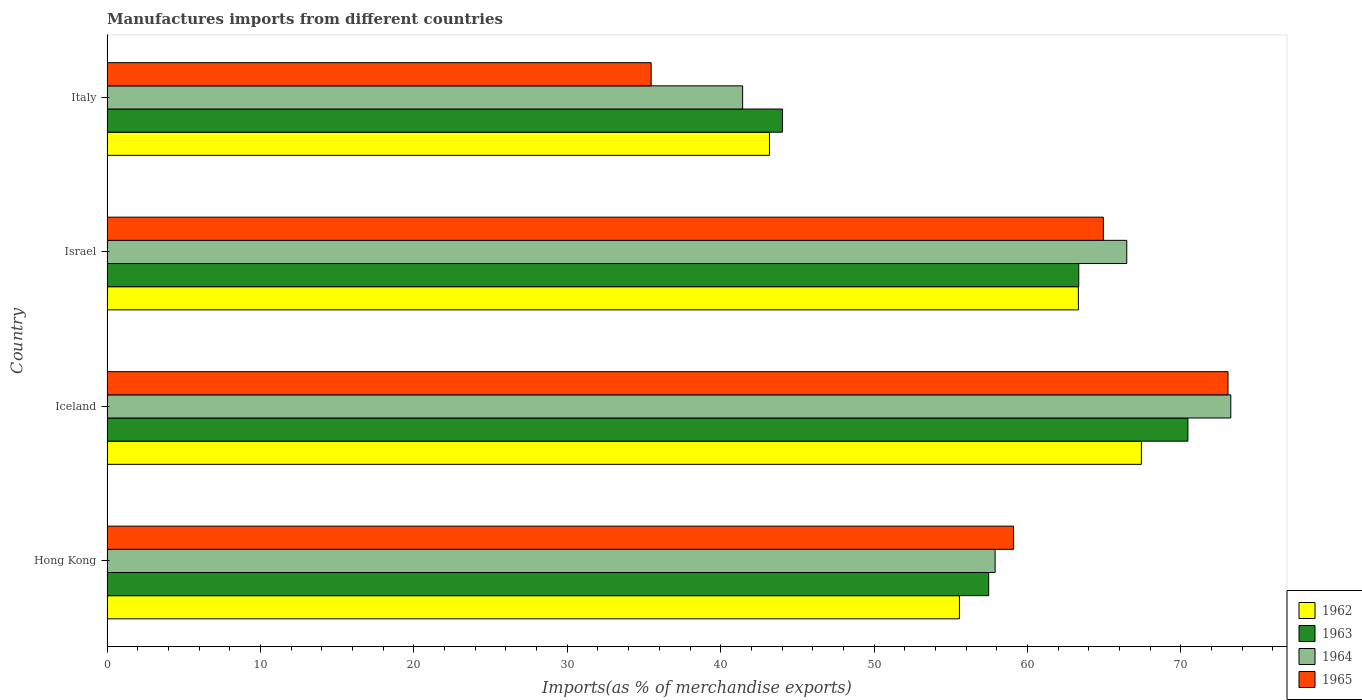How many different coloured bars are there?
Offer a terse response. 4. What is the label of the 4th group of bars from the top?
Ensure brevity in your answer.  Hong Kong. What is the percentage of imports to different countries in 1964 in Hong Kong?
Your answer should be compact. 57.89. Across all countries, what is the maximum percentage of imports to different countries in 1962?
Make the answer very short. 67.42. Across all countries, what is the minimum percentage of imports to different countries in 1963?
Ensure brevity in your answer.  44.02. What is the total percentage of imports to different countries in 1962 in the graph?
Offer a terse response. 229.48. What is the difference between the percentage of imports to different countries in 1964 in Iceland and that in Italy?
Give a very brief answer. 31.82. What is the difference between the percentage of imports to different countries in 1963 in Italy and the percentage of imports to different countries in 1962 in Iceland?
Your answer should be very brief. -23.4. What is the average percentage of imports to different countries in 1963 per country?
Ensure brevity in your answer.  58.82. What is the difference between the percentage of imports to different countries in 1965 and percentage of imports to different countries in 1962 in Italy?
Your answer should be very brief. -7.71. What is the ratio of the percentage of imports to different countries in 1963 in Iceland to that in Israel?
Offer a very short reply. 1.11. Is the percentage of imports to different countries in 1965 in Hong Kong less than that in Israel?
Your response must be concise. Yes. Is the difference between the percentage of imports to different countries in 1965 in Israel and Italy greater than the difference between the percentage of imports to different countries in 1962 in Israel and Italy?
Your response must be concise. Yes. What is the difference between the highest and the second highest percentage of imports to different countries in 1965?
Offer a terse response. 8.12. What is the difference between the highest and the lowest percentage of imports to different countries in 1962?
Provide a short and direct response. 24.24. In how many countries, is the percentage of imports to different countries in 1962 greater than the average percentage of imports to different countries in 1962 taken over all countries?
Ensure brevity in your answer.  2. Is the sum of the percentage of imports to different countries in 1963 in Hong Kong and Iceland greater than the maximum percentage of imports to different countries in 1965 across all countries?
Your answer should be very brief. Yes. What does the 2nd bar from the bottom in Iceland represents?
Your answer should be very brief. 1963. How many countries are there in the graph?
Offer a terse response. 4. What is the difference between two consecutive major ticks on the X-axis?
Ensure brevity in your answer.  10. Are the values on the major ticks of X-axis written in scientific E-notation?
Offer a terse response. No. Does the graph contain any zero values?
Offer a terse response. No. Where does the legend appear in the graph?
Ensure brevity in your answer.  Bottom right. How many legend labels are there?
Make the answer very short. 4. How are the legend labels stacked?
Give a very brief answer. Vertical. What is the title of the graph?
Your answer should be compact. Manufactures imports from different countries. Does "2015" appear as one of the legend labels in the graph?
Your answer should be compact. No. What is the label or title of the X-axis?
Provide a succinct answer. Imports(as % of merchandise exports). What is the Imports(as % of merchandise exports) of 1962 in Hong Kong?
Provide a succinct answer. 55.56. What is the Imports(as % of merchandise exports) in 1963 in Hong Kong?
Your answer should be very brief. 57.47. What is the Imports(as % of merchandise exports) of 1964 in Hong Kong?
Keep it short and to the point. 57.89. What is the Imports(as % of merchandise exports) in 1965 in Hong Kong?
Make the answer very short. 59.09. What is the Imports(as % of merchandise exports) of 1962 in Iceland?
Ensure brevity in your answer.  67.42. What is the Imports(as % of merchandise exports) in 1963 in Iceland?
Keep it short and to the point. 70.45. What is the Imports(as % of merchandise exports) of 1964 in Iceland?
Make the answer very short. 73.25. What is the Imports(as % of merchandise exports) of 1965 in Iceland?
Offer a terse response. 73.07. What is the Imports(as % of merchandise exports) of 1962 in Israel?
Provide a short and direct response. 63.32. What is the Imports(as % of merchandise exports) in 1963 in Israel?
Provide a short and direct response. 63.34. What is the Imports(as % of merchandise exports) in 1964 in Israel?
Your answer should be compact. 66.47. What is the Imports(as % of merchandise exports) in 1965 in Israel?
Make the answer very short. 64.94. What is the Imports(as % of merchandise exports) of 1962 in Italy?
Your answer should be compact. 43.18. What is the Imports(as % of merchandise exports) in 1963 in Italy?
Provide a short and direct response. 44.02. What is the Imports(as % of merchandise exports) in 1964 in Italy?
Offer a very short reply. 41.43. What is the Imports(as % of merchandise exports) of 1965 in Italy?
Provide a succinct answer. 35.47. Across all countries, what is the maximum Imports(as % of merchandise exports) of 1962?
Offer a very short reply. 67.42. Across all countries, what is the maximum Imports(as % of merchandise exports) of 1963?
Provide a short and direct response. 70.45. Across all countries, what is the maximum Imports(as % of merchandise exports) in 1964?
Ensure brevity in your answer.  73.25. Across all countries, what is the maximum Imports(as % of merchandise exports) in 1965?
Give a very brief answer. 73.07. Across all countries, what is the minimum Imports(as % of merchandise exports) of 1962?
Keep it short and to the point. 43.18. Across all countries, what is the minimum Imports(as % of merchandise exports) in 1963?
Offer a very short reply. 44.02. Across all countries, what is the minimum Imports(as % of merchandise exports) in 1964?
Your answer should be very brief. 41.43. Across all countries, what is the minimum Imports(as % of merchandise exports) in 1965?
Ensure brevity in your answer.  35.47. What is the total Imports(as % of merchandise exports) of 1962 in the graph?
Keep it short and to the point. 229.48. What is the total Imports(as % of merchandise exports) in 1963 in the graph?
Offer a very short reply. 235.29. What is the total Imports(as % of merchandise exports) of 1964 in the graph?
Make the answer very short. 239.04. What is the total Imports(as % of merchandise exports) of 1965 in the graph?
Provide a short and direct response. 232.57. What is the difference between the Imports(as % of merchandise exports) in 1962 in Hong Kong and that in Iceland?
Your answer should be compact. -11.86. What is the difference between the Imports(as % of merchandise exports) of 1963 in Hong Kong and that in Iceland?
Offer a very short reply. -12.98. What is the difference between the Imports(as % of merchandise exports) in 1964 in Hong Kong and that in Iceland?
Your answer should be very brief. -15.36. What is the difference between the Imports(as % of merchandise exports) of 1965 in Hong Kong and that in Iceland?
Your answer should be compact. -13.98. What is the difference between the Imports(as % of merchandise exports) in 1962 in Hong Kong and that in Israel?
Provide a short and direct response. -7.75. What is the difference between the Imports(as % of merchandise exports) in 1963 in Hong Kong and that in Israel?
Offer a very short reply. -5.87. What is the difference between the Imports(as % of merchandise exports) of 1964 in Hong Kong and that in Israel?
Your answer should be compact. -8.58. What is the difference between the Imports(as % of merchandise exports) of 1965 in Hong Kong and that in Israel?
Provide a succinct answer. -5.85. What is the difference between the Imports(as % of merchandise exports) in 1962 in Hong Kong and that in Italy?
Give a very brief answer. 12.38. What is the difference between the Imports(as % of merchandise exports) in 1963 in Hong Kong and that in Italy?
Your answer should be very brief. 13.44. What is the difference between the Imports(as % of merchandise exports) of 1964 in Hong Kong and that in Italy?
Make the answer very short. 16.46. What is the difference between the Imports(as % of merchandise exports) in 1965 in Hong Kong and that in Italy?
Your answer should be compact. 23.62. What is the difference between the Imports(as % of merchandise exports) in 1962 in Iceland and that in Israel?
Ensure brevity in your answer.  4.11. What is the difference between the Imports(as % of merchandise exports) of 1963 in Iceland and that in Israel?
Offer a terse response. 7.11. What is the difference between the Imports(as % of merchandise exports) in 1964 in Iceland and that in Israel?
Offer a very short reply. 6.78. What is the difference between the Imports(as % of merchandise exports) in 1965 in Iceland and that in Israel?
Keep it short and to the point. 8.12. What is the difference between the Imports(as % of merchandise exports) in 1962 in Iceland and that in Italy?
Your answer should be compact. 24.24. What is the difference between the Imports(as % of merchandise exports) in 1963 in Iceland and that in Italy?
Offer a very short reply. 26.43. What is the difference between the Imports(as % of merchandise exports) of 1964 in Iceland and that in Italy?
Offer a very short reply. 31.82. What is the difference between the Imports(as % of merchandise exports) of 1965 in Iceland and that in Italy?
Your response must be concise. 37.6. What is the difference between the Imports(as % of merchandise exports) in 1962 in Israel and that in Italy?
Provide a succinct answer. 20.14. What is the difference between the Imports(as % of merchandise exports) in 1963 in Israel and that in Italy?
Provide a succinct answer. 19.32. What is the difference between the Imports(as % of merchandise exports) in 1964 in Israel and that in Italy?
Offer a very short reply. 25.04. What is the difference between the Imports(as % of merchandise exports) in 1965 in Israel and that in Italy?
Offer a terse response. 29.47. What is the difference between the Imports(as % of merchandise exports) of 1962 in Hong Kong and the Imports(as % of merchandise exports) of 1963 in Iceland?
Ensure brevity in your answer.  -14.89. What is the difference between the Imports(as % of merchandise exports) of 1962 in Hong Kong and the Imports(as % of merchandise exports) of 1964 in Iceland?
Offer a very short reply. -17.69. What is the difference between the Imports(as % of merchandise exports) in 1962 in Hong Kong and the Imports(as % of merchandise exports) in 1965 in Iceland?
Your answer should be very brief. -17.51. What is the difference between the Imports(as % of merchandise exports) in 1963 in Hong Kong and the Imports(as % of merchandise exports) in 1964 in Iceland?
Your response must be concise. -15.78. What is the difference between the Imports(as % of merchandise exports) of 1963 in Hong Kong and the Imports(as % of merchandise exports) of 1965 in Iceland?
Your answer should be very brief. -15.6. What is the difference between the Imports(as % of merchandise exports) in 1964 in Hong Kong and the Imports(as % of merchandise exports) in 1965 in Iceland?
Offer a very short reply. -15.18. What is the difference between the Imports(as % of merchandise exports) of 1962 in Hong Kong and the Imports(as % of merchandise exports) of 1963 in Israel?
Provide a succinct answer. -7.78. What is the difference between the Imports(as % of merchandise exports) of 1962 in Hong Kong and the Imports(as % of merchandise exports) of 1964 in Israel?
Offer a very short reply. -10.91. What is the difference between the Imports(as % of merchandise exports) in 1962 in Hong Kong and the Imports(as % of merchandise exports) in 1965 in Israel?
Offer a terse response. -9.38. What is the difference between the Imports(as % of merchandise exports) of 1963 in Hong Kong and the Imports(as % of merchandise exports) of 1964 in Israel?
Provide a succinct answer. -9. What is the difference between the Imports(as % of merchandise exports) of 1963 in Hong Kong and the Imports(as % of merchandise exports) of 1965 in Israel?
Your answer should be very brief. -7.47. What is the difference between the Imports(as % of merchandise exports) in 1964 in Hong Kong and the Imports(as % of merchandise exports) in 1965 in Israel?
Your response must be concise. -7.06. What is the difference between the Imports(as % of merchandise exports) of 1962 in Hong Kong and the Imports(as % of merchandise exports) of 1963 in Italy?
Ensure brevity in your answer.  11.54. What is the difference between the Imports(as % of merchandise exports) in 1962 in Hong Kong and the Imports(as % of merchandise exports) in 1964 in Italy?
Make the answer very short. 14.13. What is the difference between the Imports(as % of merchandise exports) in 1962 in Hong Kong and the Imports(as % of merchandise exports) in 1965 in Italy?
Your response must be concise. 20.09. What is the difference between the Imports(as % of merchandise exports) of 1963 in Hong Kong and the Imports(as % of merchandise exports) of 1964 in Italy?
Make the answer very short. 16.04. What is the difference between the Imports(as % of merchandise exports) in 1963 in Hong Kong and the Imports(as % of merchandise exports) in 1965 in Italy?
Ensure brevity in your answer.  22. What is the difference between the Imports(as % of merchandise exports) in 1964 in Hong Kong and the Imports(as % of merchandise exports) in 1965 in Italy?
Offer a terse response. 22.42. What is the difference between the Imports(as % of merchandise exports) of 1962 in Iceland and the Imports(as % of merchandise exports) of 1963 in Israel?
Offer a terse response. 4.08. What is the difference between the Imports(as % of merchandise exports) of 1962 in Iceland and the Imports(as % of merchandise exports) of 1964 in Israel?
Provide a succinct answer. 0.95. What is the difference between the Imports(as % of merchandise exports) of 1962 in Iceland and the Imports(as % of merchandise exports) of 1965 in Israel?
Ensure brevity in your answer.  2.48. What is the difference between the Imports(as % of merchandise exports) in 1963 in Iceland and the Imports(as % of merchandise exports) in 1964 in Israel?
Ensure brevity in your answer.  3.98. What is the difference between the Imports(as % of merchandise exports) in 1963 in Iceland and the Imports(as % of merchandise exports) in 1965 in Israel?
Your answer should be compact. 5.51. What is the difference between the Imports(as % of merchandise exports) in 1964 in Iceland and the Imports(as % of merchandise exports) in 1965 in Israel?
Offer a terse response. 8.31. What is the difference between the Imports(as % of merchandise exports) in 1962 in Iceland and the Imports(as % of merchandise exports) in 1963 in Italy?
Keep it short and to the point. 23.4. What is the difference between the Imports(as % of merchandise exports) in 1962 in Iceland and the Imports(as % of merchandise exports) in 1964 in Italy?
Your answer should be compact. 25.99. What is the difference between the Imports(as % of merchandise exports) of 1962 in Iceland and the Imports(as % of merchandise exports) of 1965 in Italy?
Your answer should be compact. 31.95. What is the difference between the Imports(as % of merchandise exports) in 1963 in Iceland and the Imports(as % of merchandise exports) in 1964 in Italy?
Provide a short and direct response. 29.02. What is the difference between the Imports(as % of merchandise exports) of 1963 in Iceland and the Imports(as % of merchandise exports) of 1965 in Italy?
Your answer should be very brief. 34.99. What is the difference between the Imports(as % of merchandise exports) in 1964 in Iceland and the Imports(as % of merchandise exports) in 1965 in Italy?
Make the answer very short. 37.78. What is the difference between the Imports(as % of merchandise exports) of 1962 in Israel and the Imports(as % of merchandise exports) of 1963 in Italy?
Give a very brief answer. 19.29. What is the difference between the Imports(as % of merchandise exports) in 1962 in Israel and the Imports(as % of merchandise exports) in 1964 in Italy?
Give a very brief answer. 21.88. What is the difference between the Imports(as % of merchandise exports) of 1962 in Israel and the Imports(as % of merchandise exports) of 1965 in Italy?
Provide a short and direct response. 27.85. What is the difference between the Imports(as % of merchandise exports) of 1963 in Israel and the Imports(as % of merchandise exports) of 1964 in Italy?
Your response must be concise. 21.91. What is the difference between the Imports(as % of merchandise exports) of 1963 in Israel and the Imports(as % of merchandise exports) of 1965 in Italy?
Make the answer very short. 27.87. What is the difference between the Imports(as % of merchandise exports) in 1964 in Israel and the Imports(as % of merchandise exports) in 1965 in Italy?
Provide a succinct answer. 31. What is the average Imports(as % of merchandise exports) in 1962 per country?
Provide a short and direct response. 57.37. What is the average Imports(as % of merchandise exports) of 1963 per country?
Offer a terse response. 58.82. What is the average Imports(as % of merchandise exports) of 1964 per country?
Your response must be concise. 59.76. What is the average Imports(as % of merchandise exports) of 1965 per country?
Provide a short and direct response. 58.14. What is the difference between the Imports(as % of merchandise exports) in 1962 and Imports(as % of merchandise exports) in 1963 in Hong Kong?
Keep it short and to the point. -1.91. What is the difference between the Imports(as % of merchandise exports) in 1962 and Imports(as % of merchandise exports) in 1964 in Hong Kong?
Your answer should be compact. -2.33. What is the difference between the Imports(as % of merchandise exports) in 1962 and Imports(as % of merchandise exports) in 1965 in Hong Kong?
Provide a succinct answer. -3.53. What is the difference between the Imports(as % of merchandise exports) of 1963 and Imports(as % of merchandise exports) of 1964 in Hong Kong?
Offer a terse response. -0.42. What is the difference between the Imports(as % of merchandise exports) in 1963 and Imports(as % of merchandise exports) in 1965 in Hong Kong?
Give a very brief answer. -1.62. What is the difference between the Imports(as % of merchandise exports) of 1964 and Imports(as % of merchandise exports) of 1965 in Hong Kong?
Your response must be concise. -1.2. What is the difference between the Imports(as % of merchandise exports) in 1962 and Imports(as % of merchandise exports) in 1963 in Iceland?
Provide a succinct answer. -3.03. What is the difference between the Imports(as % of merchandise exports) of 1962 and Imports(as % of merchandise exports) of 1964 in Iceland?
Provide a succinct answer. -5.83. What is the difference between the Imports(as % of merchandise exports) in 1962 and Imports(as % of merchandise exports) in 1965 in Iceland?
Provide a succinct answer. -5.64. What is the difference between the Imports(as % of merchandise exports) of 1963 and Imports(as % of merchandise exports) of 1964 in Iceland?
Offer a very short reply. -2.8. What is the difference between the Imports(as % of merchandise exports) of 1963 and Imports(as % of merchandise exports) of 1965 in Iceland?
Give a very brief answer. -2.61. What is the difference between the Imports(as % of merchandise exports) of 1964 and Imports(as % of merchandise exports) of 1965 in Iceland?
Your response must be concise. 0.18. What is the difference between the Imports(as % of merchandise exports) in 1962 and Imports(as % of merchandise exports) in 1963 in Israel?
Your answer should be compact. -0.02. What is the difference between the Imports(as % of merchandise exports) of 1962 and Imports(as % of merchandise exports) of 1964 in Israel?
Offer a very short reply. -3.15. What is the difference between the Imports(as % of merchandise exports) in 1962 and Imports(as % of merchandise exports) in 1965 in Israel?
Offer a very short reply. -1.63. What is the difference between the Imports(as % of merchandise exports) of 1963 and Imports(as % of merchandise exports) of 1964 in Israel?
Your response must be concise. -3.13. What is the difference between the Imports(as % of merchandise exports) of 1963 and Imports(as % of merchandise exports) of 1965 in Israel?
Offer a very short reply. -1.6. What is the difference between the Imports(as % of merchandise exports) in 1964 and Imports(as % of merchandise exports) in 1965 in Israel?
Your answer should be compact. 1.53. What is the difference between the Imports(as % of merchandise exports) of 1962 and Imports(as % of merchandise exports) of 1963 in Italy?
Offer a very short reply. -0.84. What is the difference between the Imports(as % of merchandise exports) of 1962 and Imports(as % of merchandise exports) of 1964 in Italy?
Your answer should be very brief. 1.75. What is the difference between the Imports(as % of merchandise exports) in 1962 and Imports(as % of merchandise exports) in 1965 in Italy?
Your answer should be very brief. 7.71. What is the difference between the Imports(as % of merchandise exports) of 1963 and Imports(as % of merchandise exports) of 1964 in Italy?
Your response must be concise. 2.59. What is the difference between the Imports(as % of merchandise exports) in 1963 and Imports(as % of merchandise exports) in 1965 in Italy?
Give a very brief answer. 8.56. What is the difference between the Imports(as % of merchandise exports) in 1964 and Imports(as % of merchandise exports) in 1965 in Italy?
Your answer should be very brief. 5.96. What is the ratio of the Imports(as % of merchandise exports) in 1962 in Hong Kong to that in Iceland?
Offer a terse response. 0.82. What is the ratio of the Imports(as % of merchandise exports) in 1963 in Hong Kong to that in Iceland?
Provide a succinct answer. 0.82. What is the ratio of the Imports(as % of merchandise exports) in 1964 in Hong Kong to that in Iceland?
Give a very brief answer. 0.79. What is the ratio of the Imports(as % of merchandise exports) in 1965 in Hong Kong to that in Iceland?
Your answer should be very brief. 0.81. What is the ratio of the Imports(as % of merchandise exports) in 1962 in Hong Kong to that in Israel?
Offer a very short reply. 0.88. What is the ratio of the Imports(as % of merchandise exports) of 1963 in Hong Kong to that in Israel?
Offer a terse response. 0.91. What is the ratio of the Imports(as % of merchandise exports) of 1964 in Hong Kong to that in Israel?
Provide a succinct answer. 0.87. What is the ratio of the Imports(as % of merchandise exports) in 1965 in Hong Kong to that in Israel?
Ensure brevity in your answer.  0.91. What is the ratio of the Imports(as % of merchandise exports) of 1962 in Hong Kong to that in Italy?
Your answer should be compact. 1.29. What is the ratio of the Imports(as % of merchandise exports) of 1963 in Hong Kong to that in Italy?
Ensure brevity in your answer.  1.31. What is the ratio of the Imports(as % of merchandise exports) of 1964 in Hong Kong to that in Italy?
Provide a short and direct response. 1.4. What is the ratio of the Imports(as % of merchandise exports) in 1965 in Hong Kong to that in Italy?
Provide a short and direct response. 1.67. What is the ratio of the Imports(as % of merchandise exports) in 1962 in Iceland to that in Israel?
Give a very brief answer. 1.06. What is the ratio of the Imports(as % of merchandise exports) of 1963 in Iceland to that in Israel?
Make the answer very short. 1.11. What is the ratio of the Imports(as % of merchandise exports) in 1964 in Iceland to that in Israel?
Your answer should be compact. 1.1. What is the ratio of the Imports(as % of merchandise exports) in 1965 in Iceland to that in Israel?
Your response must be concise. 1.13. What is the ratio of the Imports(as % of merchandise exports) of 1962 in Iceland to that in Italy?
Your answer should be very brief. 1.56. What is the ratio of the Imports(as % of merchandise exports) in 1963 in Iceland to that in Italy?
Your response must be concise. 1.6. What is the ratio of the Imports(as % of merchandise exports) of 1964 in Iceland to that in Italy?
Provide a succinct answer. 1.77. What is the ratio of the Imports(as % of merchandise exports) of 1965 in Iceland to that in Italy?
Ensure brevity in your answer.  2.06. What is the ratio of the Imports(as % of merchandise exports) of 1962 in Israel to that in Italy?
Your answer should be compact. 1.47. What is the ratio of the Imports(as % of merchandise exports) in 1963 in Israel to that in Italy?
Keep it short and to the point. 1.44. What is the ratio of the Imports(as % of merchandise exports) of 1964 in Israel to that in Italy?
Make the answer very short. 1.6. What is the ratio of the Imports(as % of merchandise exports) of 1965 in Israel to that in Italy?
Provide a succinct answer. 1.83. What is the difference between the highest and the second highest Imports(as % of merchandise exports) of 1962?
Offer a very short reply. 4.11. What is the difference between the highest and the second highest Imports(as % of merchandise exports) of 1963?
Ensure brevity in your answer.  7.11. What is the difference between the highest and the second highest Imports(as % of merchandise exports) of 1964?
Provide a short and direct response. 6.78. What is the difference between the highest and the second highest Imports(as % of merchandise exports) in 1965?
Provide a short and direct response. 8.12. What is the difference between the highest and the lowest Imports(as % of merchandise exports) in 1962?
Your response must be concise. 24.24. What is the difference between the highest and the lowest Imports(as % of merchandise exports) of 1963?
Make the answer very short. 26.43. What is the difference between the highest and the lowest Imports(as % of merchandise exports) in 1964?
Your answer should be very brief. 31.82. What is the difference between the highest and the lowest Imports(as % of merchandise exports) in 1965?
Provide a short and direct response. 37.6. 